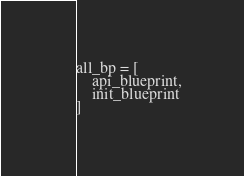<code> <loc_0><loc_0><loc_500><loc_500><_Python_>all_bp = [
    api_blueprint,
    init_blueprint
]
</code> 